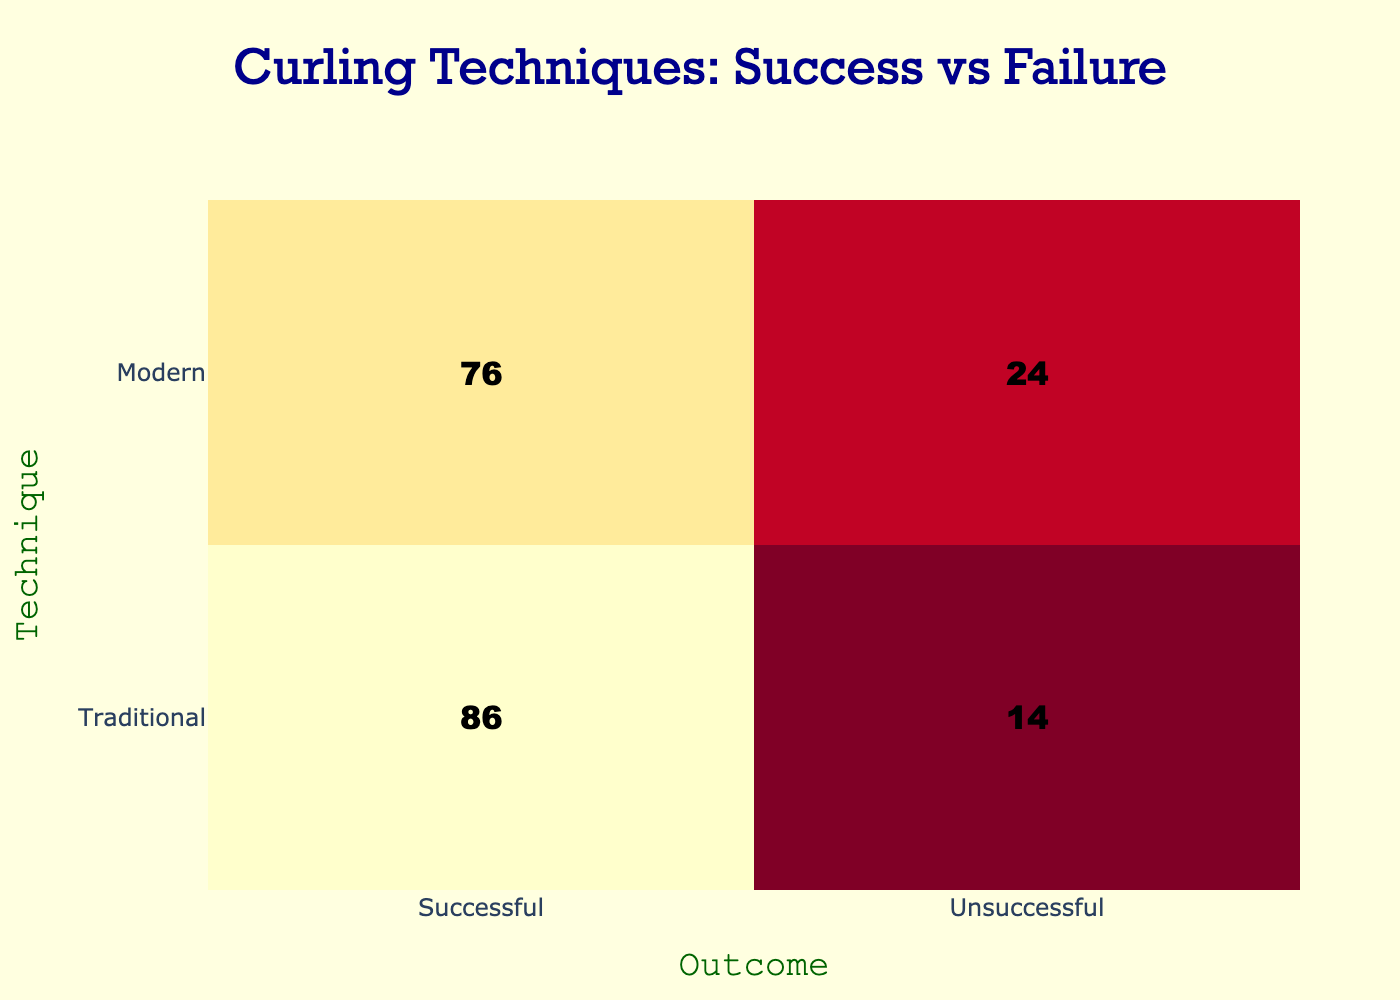What is the total number of successful outcomes for traditional techniques? To find the total number of successful outcomes for traditional techniques, we add the successful outcomes from each entry: 85 + 84 + 88 + 90 + 82 + 87 + 89 + 86 = 700.
Answer: 700 What is the average number of unsuccessful outcomes for modern techniques? To find the average for modern techniques, we first sum the unsuccessful outcomes: 25 + 22 + 26 + 23 + 28 + 21 + 27 + 24 = 202. Then we divide by the number of entries (8): 202 / 8 = 25.25, which rounds to 25.
Answer: 25 Is the number of successful outcomes higher for traditional techniques than modern techniques? The total successful outcomes for traditional techniques is 700, while for modern techniques, it is 75 + 78 + 74 + 77 + 72 + 79 + 73 + 76 = 600. Since 700 > 600, the answer is yes.
Answer: Yes What is the difference between the average successful outcomes of traditional and modern techniques? First, calculate the average successful outcomes for traditional techniques, which is 700 / 8 = 87.5. Then for modern techniques, it is 600 / 8 = 75. The difference is 87.5 - 75 = 12.5.
Answer: 12.5 What percentage of total outcomes for traditional curling techniques were unsuccessful? The total outcomes for traditional techniques are 700 successful + 120 unsuccessful = 820. The percentage of unsuccessful outcomes is (120 / 820) * 100 = 14.63%.
Answer: 14.63% 